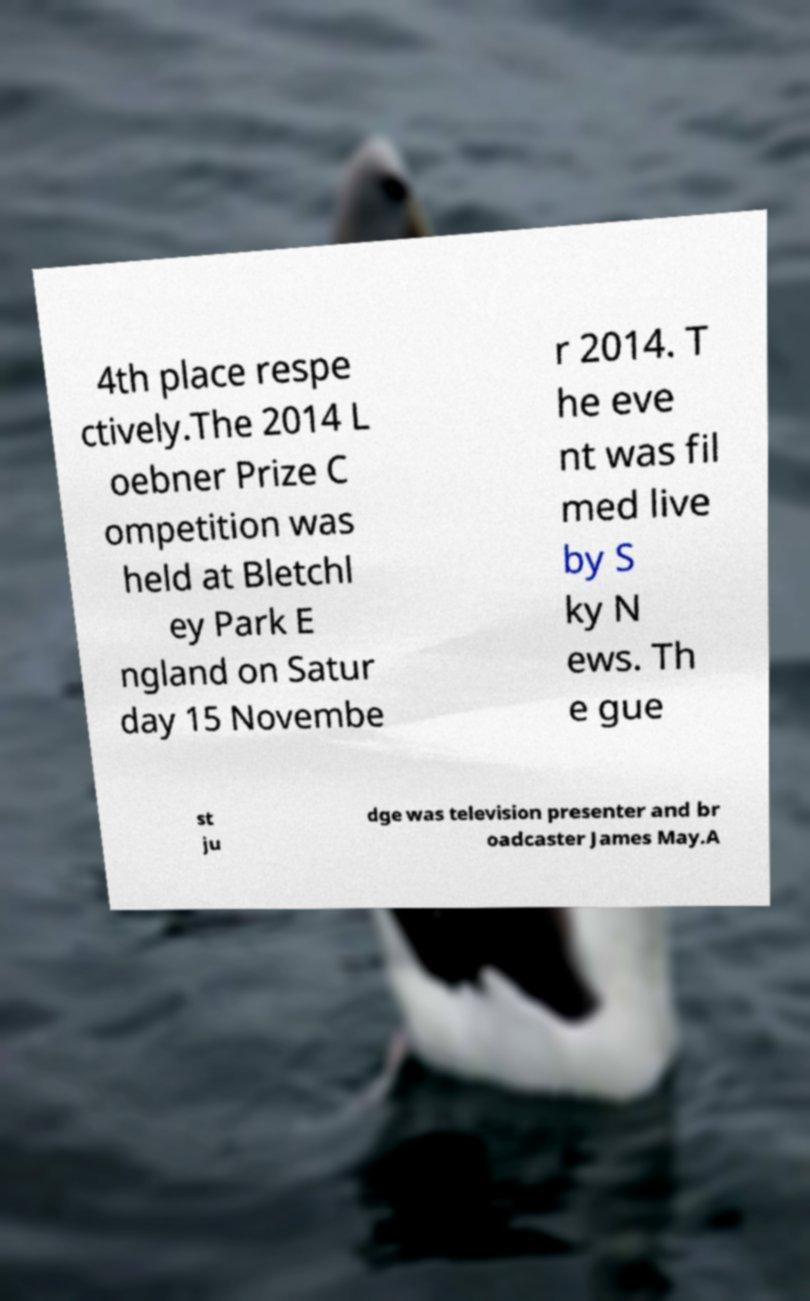Please read and relay the text visible in this image. What does it say? 4th place respe ctively.The 2014 L oebner Prize C ompetition was held at Bletchl ey Park E ngland on Satur day 15 Novembe r 2014. T he eve nt was fil med live by S ky N ews. Th e gue st ju dge was television presenter and br oadcaster James May.A 